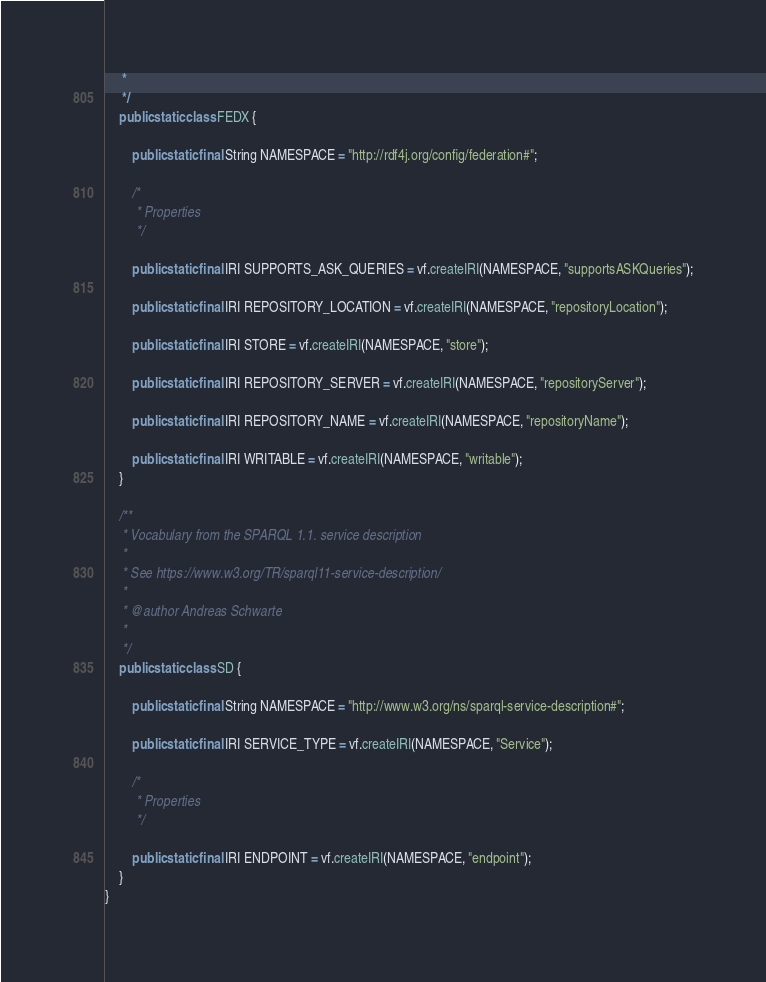<code> <loc_0><loc_0><loc_500><loc_500><_Java_>	 *
	 */
	public static class FEDX {

		public static final String NAMESPACE = "http://rdf4j.org/config/federation#";

		/*
		 * Properties
		 */

		public static final IRI SUPPORTS_ASK_QUERIES = vf.createIRI(NAMESPACE, "supportsASKQueries");

		public static final IRI REPOSITORY_LOCATION = vf.createIRI(NAMESPACE, "repositoryLocation");

		public static final IRI STORE = vf.createIRI(NAMESPACE, "store");

		public static final IRI REPOSITORY_SERVER = vf.createIRI(NAMESPACE, "repositoryServer");

		public static final IRI REPOSITORY_NAME = vf.createIRI(NAMESPACE, "repositoryName");

		public static final IRI WRITABLE = vf.createIRI(NAMESPACE, "writable");
	}

	/**
	 * Vocabulary from the SPARQL 1.1. service description
	 * 
	 * See https://www.w3.org/TR/sparql11-service-description/
	 * 
	 * @author Andreas Schwarte
	 *
	 */
	public static class SD {

		public static final String NAMESPACE = "http://www.w3.org/ns/sparql-service-description#";

		public static final IRI SERVICE_TYPE = vf.createIRI(NAMESPACE, "Service");

		/*
		 * Properties
		 */

		public static final IRI ENDPOINT = vf.createIRI(NAMESPACE, "endpoint");
	}
}
</code> 